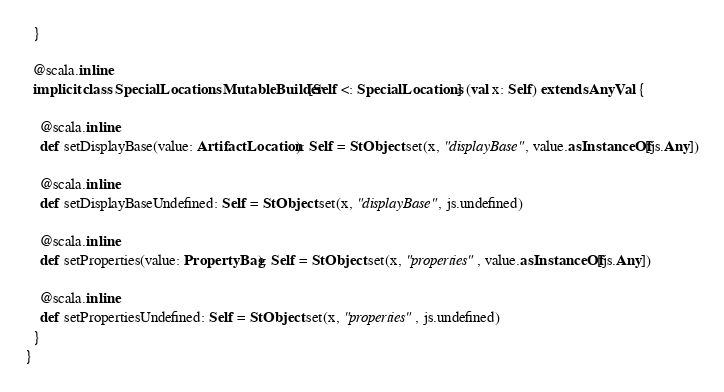<code> <loc_0><loc_0><loc_500><loc_500><_Scala_>  }
  
  @scala.inline
  implicit class SpecialLocationsMutableBuilder[Self <: SpecialLocations] (val x: Self) extends AnyVal {
    
    @scala.inline
    def setDisplayBase(value: ArtifactLocation): Self = StObject.set(x, "displayBase", value.asInstanceOf[js.Any])
    
    @scala.inline
    def setDisplayBaseUndefined: Self = StObject.set(x, "displayBase", js.undefined)
    
    @scala.inline
    def setProperties(value: PropertyBag): Self = StObject.set(x, "properties", value.asInstanceOf[js.Any])
    
    @scala.inline
    def setPropertiesUndefined: Self = StObject.set(x, "properties", js.undefined)
  }
}
</code> 